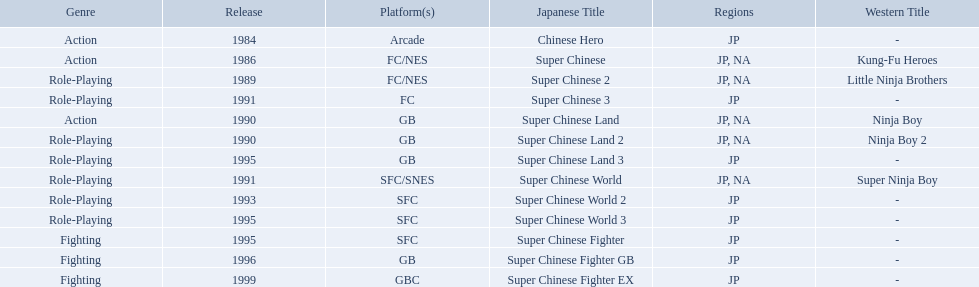Super ninja world was released in what countries? JP, NA. What was the original name for this title? Super Chinese World. 